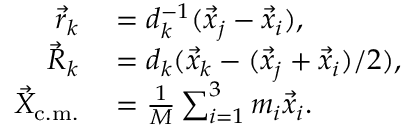<formula> <loc_0><loc_0><loc_500><loc_500>\begin{array} { r l } { \vec { r } _ { k } } & = d _ { k } ^ { - 1 } ( \vec { x } _ { j } - \vec { x } _ { i } ) , } \\ { \vec { R } _ { k } } & = d _ { k } ( \vec { x } _ { k } - ( \vec { x } _ { j } + \vec { x } _ { i } ) / 2 ) , } \\ { \vec { X } _ { c . m . } } & = \frac { 1 } { M } \sum _ { i = 1 } ^ { 3 } m _ { i } \vec { x } _ { i } . } \end{array}</formula> 